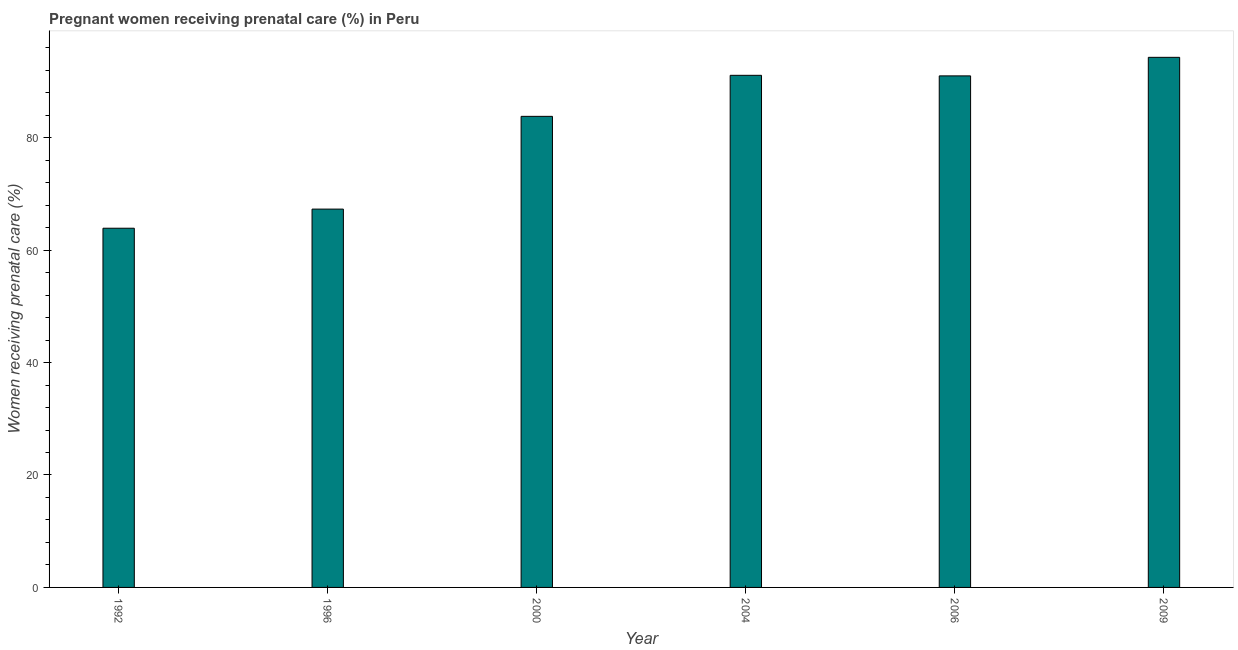Does the graph contain any zero values?
Ensure brevity in your answer.  No. What is the title of the graph?
Make the answer very short. Pregnant women receiving prenatal care (%) in Peru. What is the label or title of the Y-axis?
Provide a succinct answer. Women receiving prenatal care (%). What is the percentage of pregnant women receiving prenatal care in 2006?
Ensure brevity in your answer.  91. Across all years, what is the maximum percentage of pregnant women receiving prenatal care?
Keep it short and to the point. 94.3. Across all years, what is the minimum percentage of pregnant women receiving prenatal care?
Your answer should be compact. 63.9. In which year was the percentage of pregnant women receiving prenatal care maximum?
Ensure brevity in your answer.  2009. In which year was the percentage of pregnant women receiving prenatal care minimum?
Your response must be concise. 1992. What is the sum of the percentage of pregnant women receiving prenatal care?
Give a very brief answer. 491.4. What is the average percentage of pregnant women receiving prenatal care per year?
Make the answer very short. 81.9. What is the median percentage of pregnant women receiving prenatal care?
Ensure brevity in your answer.  87.4. Do a majority of the years between 2000 and 1996 (inclusive) have percentage of pregnant women receiving prenatal care greater than 8 %?
Give a very brief answer. No. What is the ratio of the percentage of pregnant women receiving prenatal care in 1996 to that in 2000?
Your answer should be very brief. 0.8. Is the difference between the percentage of pregnant women receiving prenatal care in 2004 and 2006 greater than the difference between any two years?
Your response must be concise. No. What is the difference between the highest and the second highest percentage of pregnant women receiving prenatal care?
Ensure brevity in your answer.  3.2. Is the sum of the percentage of pregnant women receiving prenatal care in 1996 and 2009 greater than the maximum percentage of pregnant women receiving prenatal care across all years?
Keep it short and to the point. Yes. What is the difference between the highest and the lowest percentage of pregnant women receiving prenatal care?
Offer a very short reply. 30.4. Are all the bars in the graph horizontal?
Your response must be concise. No. Are the values on the major ticks of Y-axis written in scientific E-notation?
Give a very brief answer. No. What is the Women receiving prenatal care (%) in 1992?
Provide a succinct answer. 63.9. What is the Women receiving prenatal care (%) in 1996?
Your answer should be compact. 67.3. What is the Women receiving prenatal care (%) of 2000?
Ensure brevity in your answer.  83.8. What is the Women receiving prenatal care (%) of 2004?
Your answer should be compact. 91.1. What is the Women receiving prenatal care (%) of 2006?
Your answer should be compact. 91. What is the Women receiving prenatal care (%) in 2009?
Your response must be concise. 94.3. What is the difference between the Women receiving prenatal care (%) in 1992 and 1996?
Provide a succinct answer. -3.4. What is the difference between the Women receiving prenatal care (%) in 1992 and 2000?
Ensure brevity in your answer.  -19.9. What is the difference between the Women receiving prenatal care (%) in 1992 and 2004?
Ensure brevity in your answer.  -27.2. What is the difference between the Women receiving prenatal care (%) in 1992 and 2006?
Keep it short and to the point. -27.1. What is the difference between the Women receiving prenatal care (%) in 1992 and 2009?
Make the answer very short. -30.4. What is the difference between the Women receiving prenatal care (%) in 1996 and 2000?
Offer a very short reply. -16.5. What is the difference between the Women receiving prenatal care (%) in 1996 and 2004?
Offer a very short reply. -23.8. What is the difference between the Women receiving prenatal care (%) in 1996 and 2006?
Keep it short and to the point. -23.7. What is the difference between the Women receiving prenatal care (%) in 2000 and 2004?
Your answer should be compact. -7.3. What is the difference between the Women receiving prenatal care (%) in 2000 and 2006?
Your response must be concise. -7.2. What is the difference between the Women receiving prenatal care (%) in 2000 and 2009?
Give a very brief answer. -10.5. What is the difference between the Women receiving prenatal care (%) in 2004 and 2009?
Keep it short and to the point. -3.2. What is the difference between the Women receiving prenatal care (%) in 2006 and 2009?
Keep it short and to the point. -3.3. What is the ratio of the Women receiving prenatal care (%) in 1992 to that in 1996?
Your answer should be compact. 0.95. What is the ratio of the Women receiving prenatal care (%) in 1992 to that in 2000?
Your answer should be very brief. 0.76. What is the ratio of the Women receiving prenatal care (%) in 1992 to that in 2004?
Provide a succinct answer. 0.7. What is the ratio of the Women receiving prenatal care (%) in 1992 to that in 2006?
Offer a terse response. 0.7. What is the ratio of the Women receiving prenatal care (%) in 1992 to that in 2009?
Keep it short and to the point. 0.68. What is the ratio of the Women receiving prenatal care (%) in 1996 to that in 2000?
Your answer should be compact. 0.8. What is the ratio of the Women receiving prenatal care (%) in 1996 to that in 2004?
Provide a short and direct response. 0.74. What is the ratio of the Women receiving prenatal care (%) in 1996 to that in 2006?
Your answer should be compact. 0.74. What is the ratio of the Women receiving prenatal care (%) in 1996 to that in 2009?
Offer a terse response. 0.71. What is the ratio of the Women receiving prenatal care (%) in 2000 to that in 2004?
Make the answer very short. 0.92. What is the ratio of the Women receiving prenatal care (%) in 2000 to that in 2006?
Provide a short and direct response. 0.92. What is the ratio of the Women receiving prenatal care (%) in 2000 to that in 2009?
Your answer should be very brief. 0.89. What is the ratio of the Women receiving prenatal care (%) in 2004 to that in 2006?
Offer a terse response. 1. What is the ratio of the Women receiving prenatal care (%) in 2004 to that in 2009?
Your answer should be compact. 0.97. 